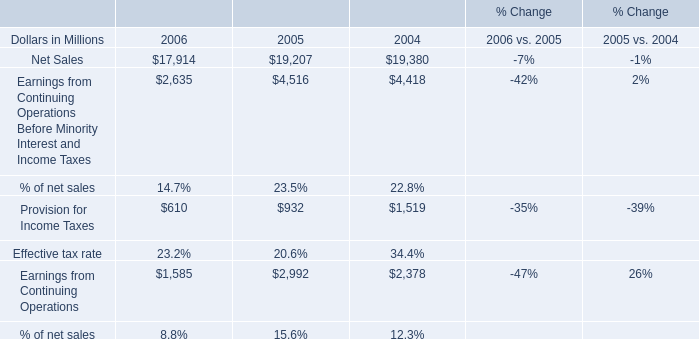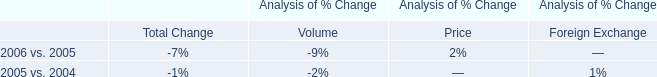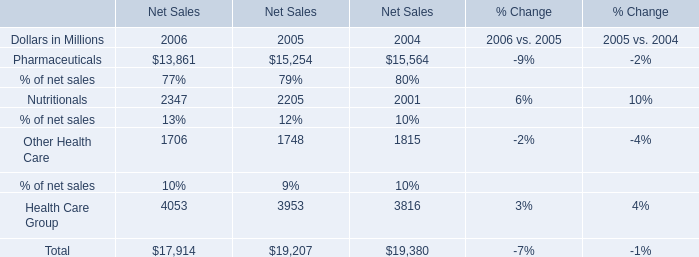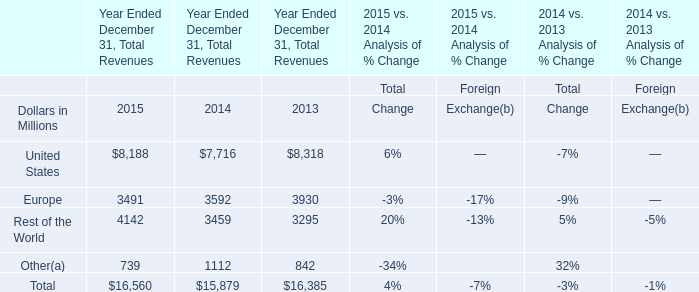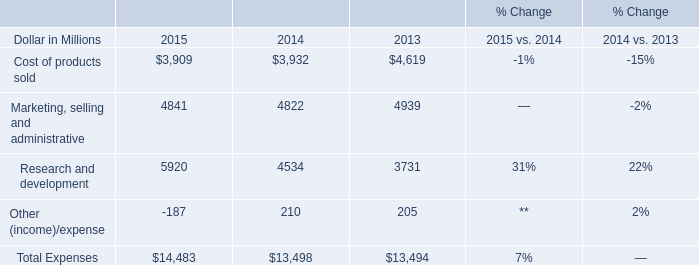What is the sum of Europe for Year Ended December 31, Total Revenues in 2014 and Cost of products sold in 2015? (in Million) 
Computations: (3909 + 3592)
Answer: 7501.0. 